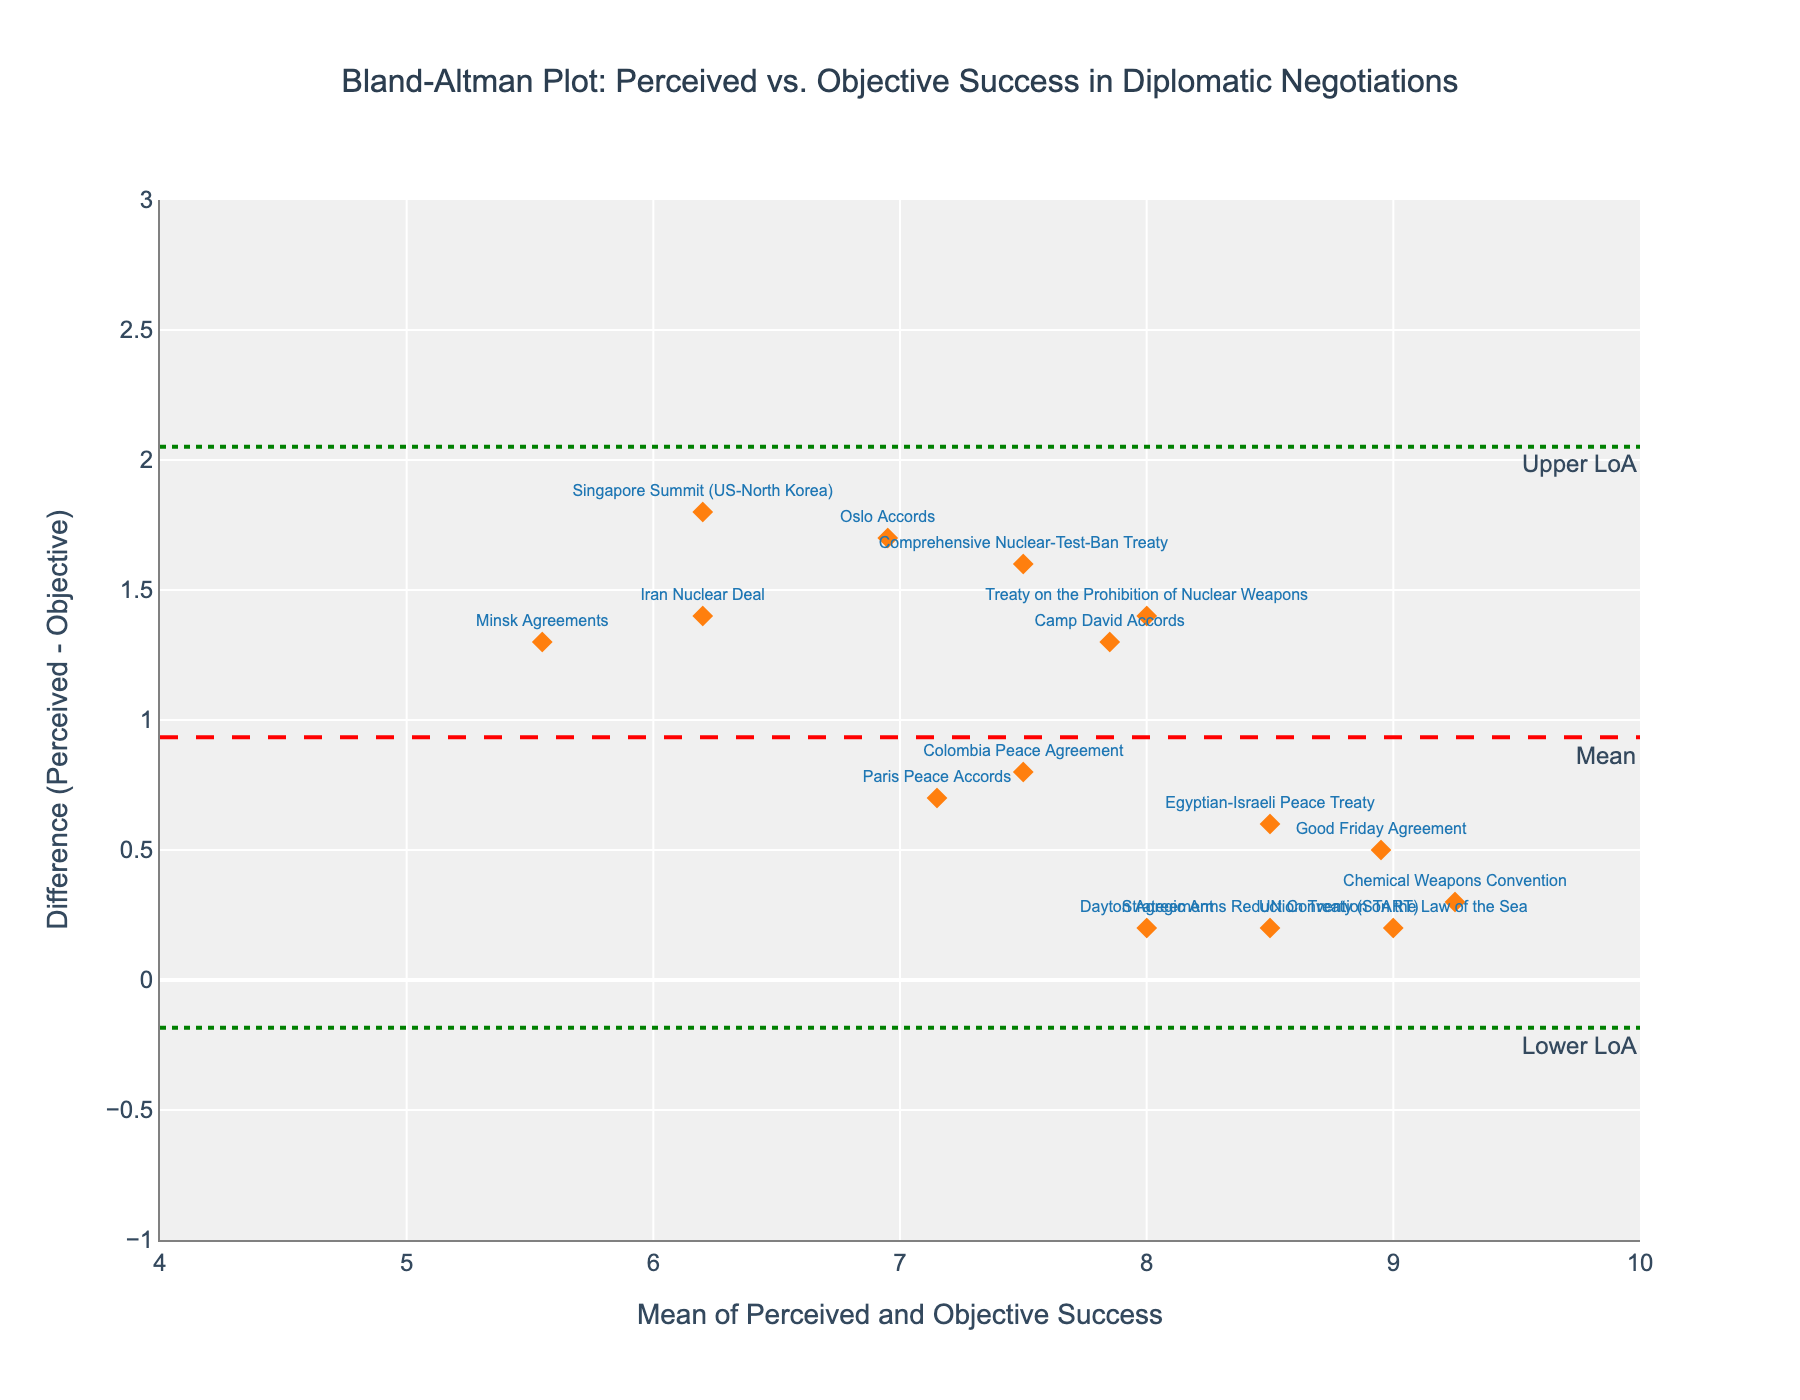What is the title of the plot? The title is commonly located at the top of the plot and clearly states what the plot represents. Here, it reads "Bland-Altman Plot: Perceived vs. Objective Success in Diplomatic Negotiations".
Answer: Bland-Altman Plot: Perceived vs. Objective Success in Diplomatic Negotiations How many data points are shown in the figure? Each marker on the plot represents one data point corresponding to different negotiations. By counting the markers, we find there are 15 data points.
Answer: 15 What do the x-axis and y-axis represent? The x-axis indicates the mean of perceived and objective success, and the y-axis represents the difference between perceived and objective success (Perceived - Objective). This can be inferred from the axis titles.
Answer: The x-axis represents the mean of perceived and objective success, and the y-axis represents the difference (Perceived - Objective) Which negotiation has the highest perceived success compared to its objective success? To find this, we need to look for the data point with the highest positive value on the y-axis, as this indicates the largest difference where perceived success exceeds objective success. The "Singapore Summit (US-North Korea)" appears to have this highest positive difference.
Answer: Singapore Summit (US-North Korea) What are the limits of agreement in the plot? Limits of agreement are represented by the dotted lines and their y-values can be noted from the plot annotations labeled "Lower LoA" and "Upper LoA". These values are approximately 0.35 and 1.94 respectively.
Answer: 0.35 (Lower), 1.94 (Upper) Calculate the mean of success (both perceived and objective) for the Camp David Accords. The mean is calculated by averaging the perceived success (8.5) and objective success (7.2) for the Camp David Accords. Mean = (8.5 + 7.2) / 2 = 7.85.
Answer: 7.85 Is there any negotiation where the perceived and objective successes are almost equal? This would be reflected by a y-axis value (difference) close to zero. The "Chemical Weapons Convention" is very close to zero, indicating almost equal perceived and objective successes.
Answer: Chemical Weapons Convention What is the mean difference in the plot? The mean difference is explicitly annotated in the figure, represented by a dashed red line labeled "Mean". This value is approximately 1.15.
Answer: 1.15 Which negotiation has the largest negative difference (perceived - objective success)? A negative difference indicates perceived success is less than objective success. By locating the lowest value on the y-axis, we find the "Minsk Agreements" has the largest negative difference.
Answer: Minsk Agreements What can you infer about negotiations with a mean success greater than 8 but a positive difference (Perceived greater than Objective)? These points are located on the right side of the plot with y-values above zero. Examples include the "Camp David Accords" and "Egyptian-Israeli Peace Treaty". This suggests these negotiations were perceived more successful than their objective outcomes, despite high mean success.
Answer: They are perceived more successful than their objective outcomes 